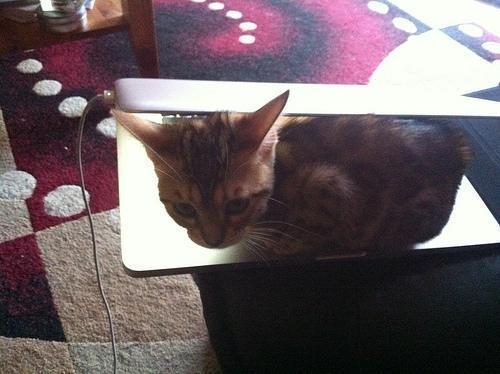How many cats are there?
Give a very brief answer. 1. 